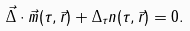Convert formula to latex. <formula><loc_0><loc_0><loc_500><loc_500>\vec { \Delta } \cdot \vec { m } ( \tau , \vec { r } ) + \Delta _ { \tau } n ( \tau , \vec { r } ) = 0 .</formula> 